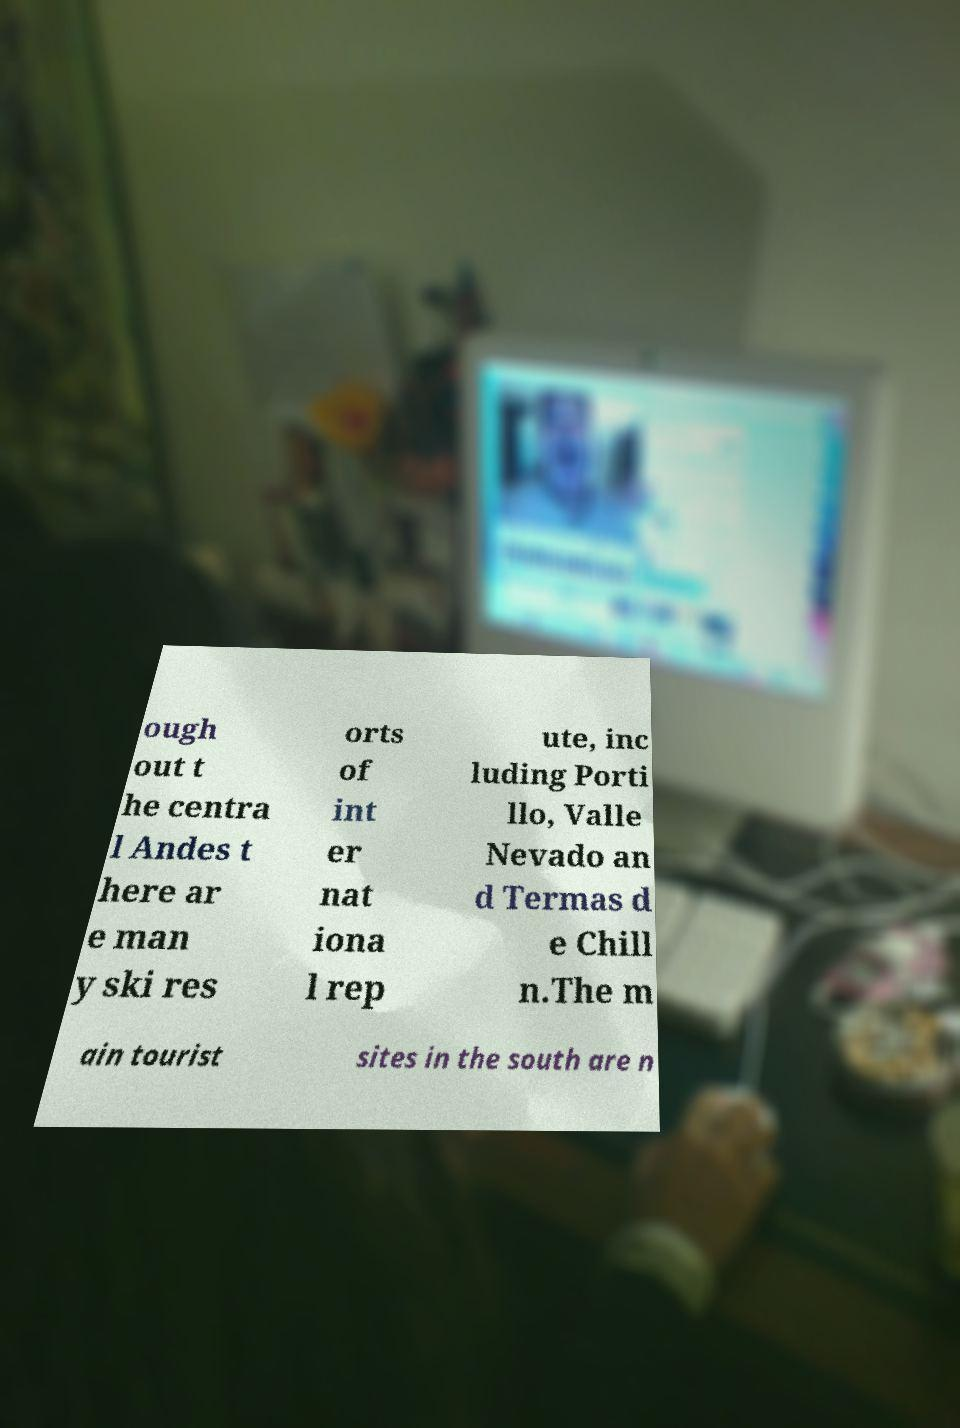There's text embedded in this image that I need extracted. Can you transcribe it verbatim? ough out t he centra l Andes t here ar e man y ski res orts of int er nat iona l rep ute, inc luding Porti llo, Valle Nevado an d Termas d e Chill n.The m ain tourist sites in the south are n 